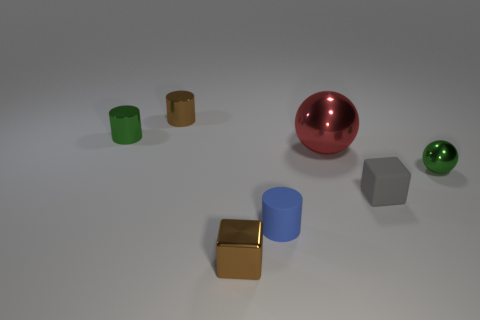How do the shadows in the image give us clues about the light source? The shadows in the image are soft-edged and fall to the right of the objects, indicating a light source to the left of the scene. The uniformity and length of the shadows suggest the light source is not too close to the objects, allowing the shadows to stretch out. The softness of the shadows implies that the light source has a larger surface area, such as a window or a diffused artificial light. This information helps us deduce that the lighting is likely ambient and diffused rather than direct and pinpointed. 